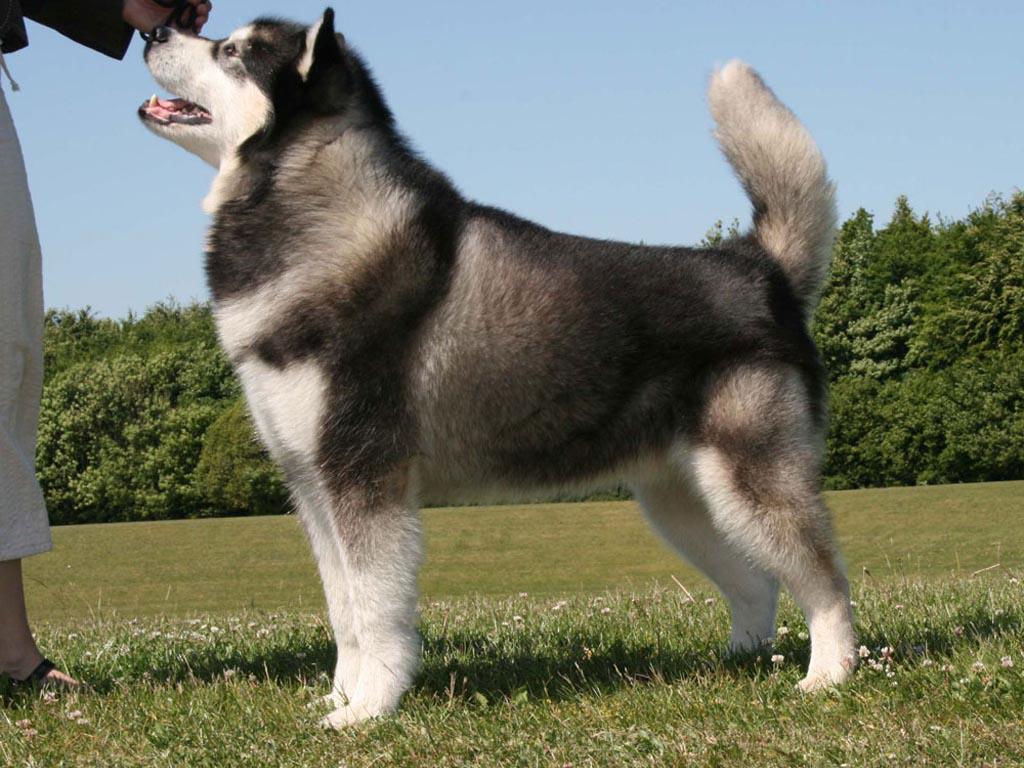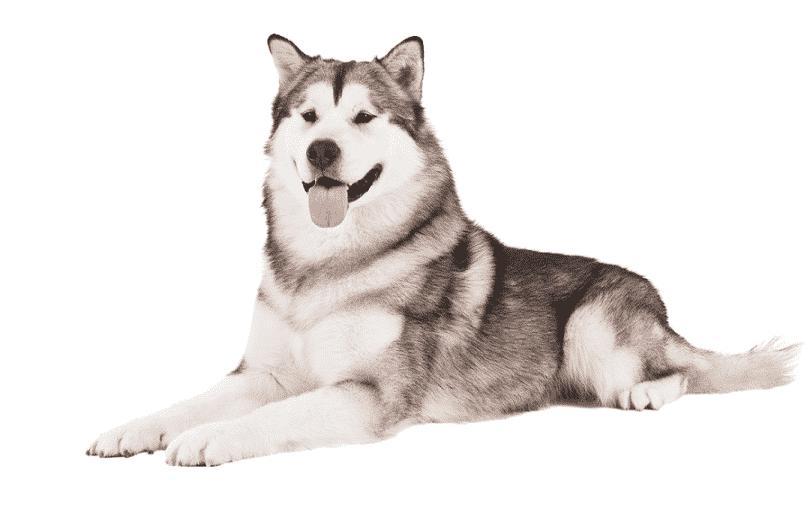The first image is the image on the left, the second image is the image on the right. Examine the images to the left and right. Is the description "All dogs are standing with bodies in profile, at least one with its tail curled inward toward its back, and the dogs in the left and right images gaze in the same direction." accurate? Answer yes or no. No. The first image is the image on the left, the second image is the image on the right. Analyze the images presented: Is the assertion "The right image contains one dog standing on green grass." valid? Answer yes or no. No. 